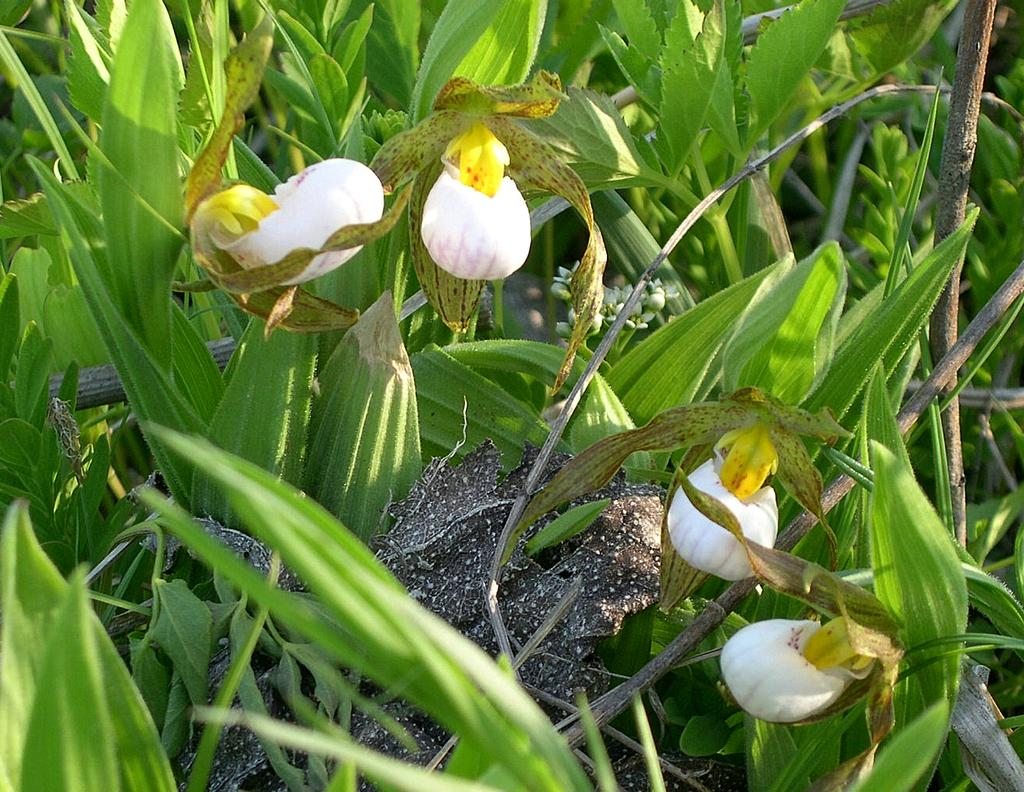What type of flowers are in the foreground of the image? There are white color flowers in the foreground of the image. What are the flowers connected to in the image? The flowers are associated with plants. What else can be seen in the image besides the flowers? There are sticks visible in the image. What else is present in the image besides the flowers and sticks? There are plants in the image. What type of laborer can be seen working in the image? There is no laborer present in the image; it features white color flowers, plants, and sticks. What offer is being made by the plants in the image? There is no offer being made by the plants in the image; they are simply growing and associated with the flowers and sticks. 